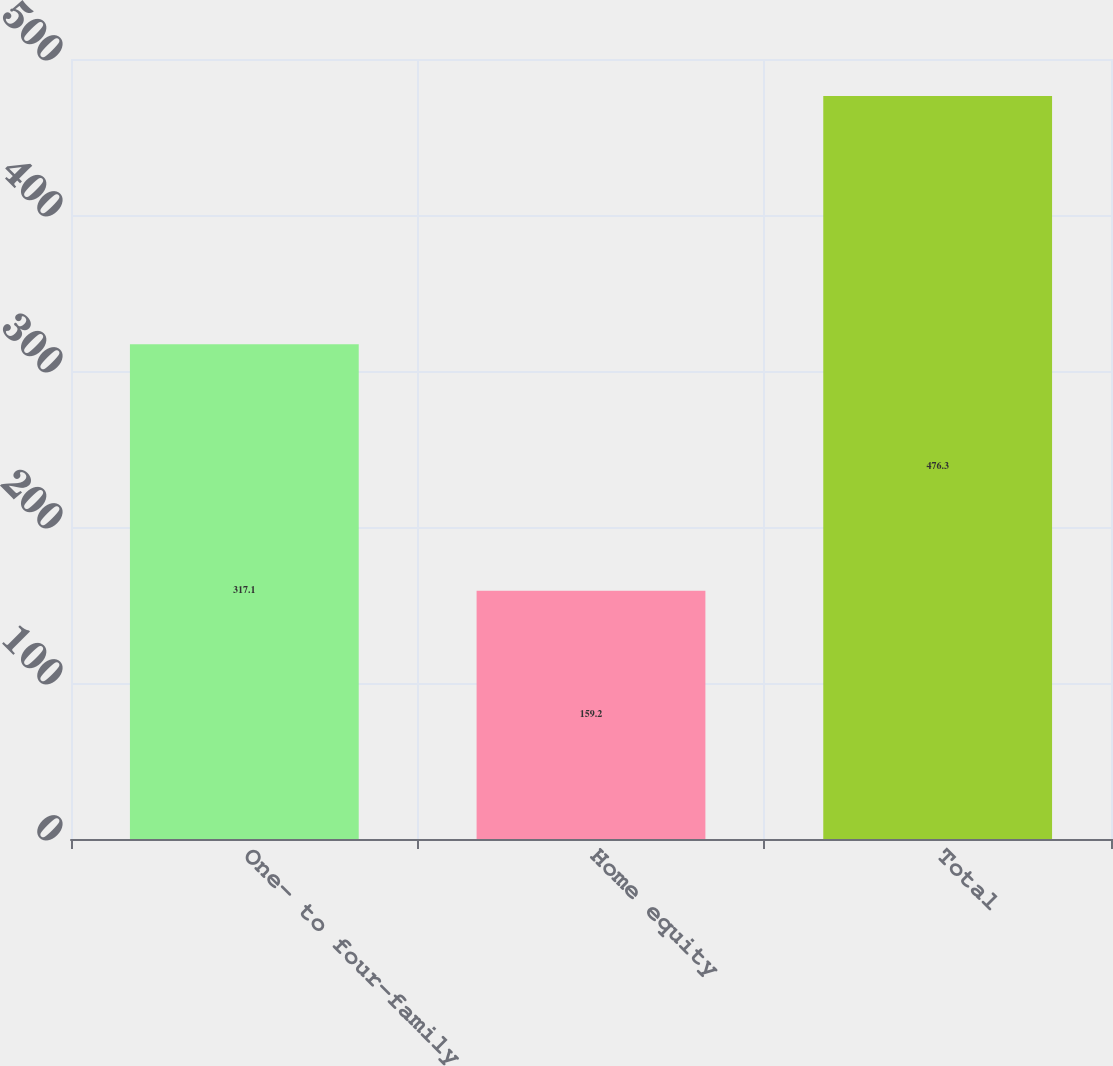Convert chart to OTSL. <chart><loc_0><loc_0><loc_500><loc_500><bar_chart><fcel>One- to four-family<fcel>Home equity<fcel>Total<nl><fcel>317.1<fcel>159.2<fcel>476.3<nl></chart> 